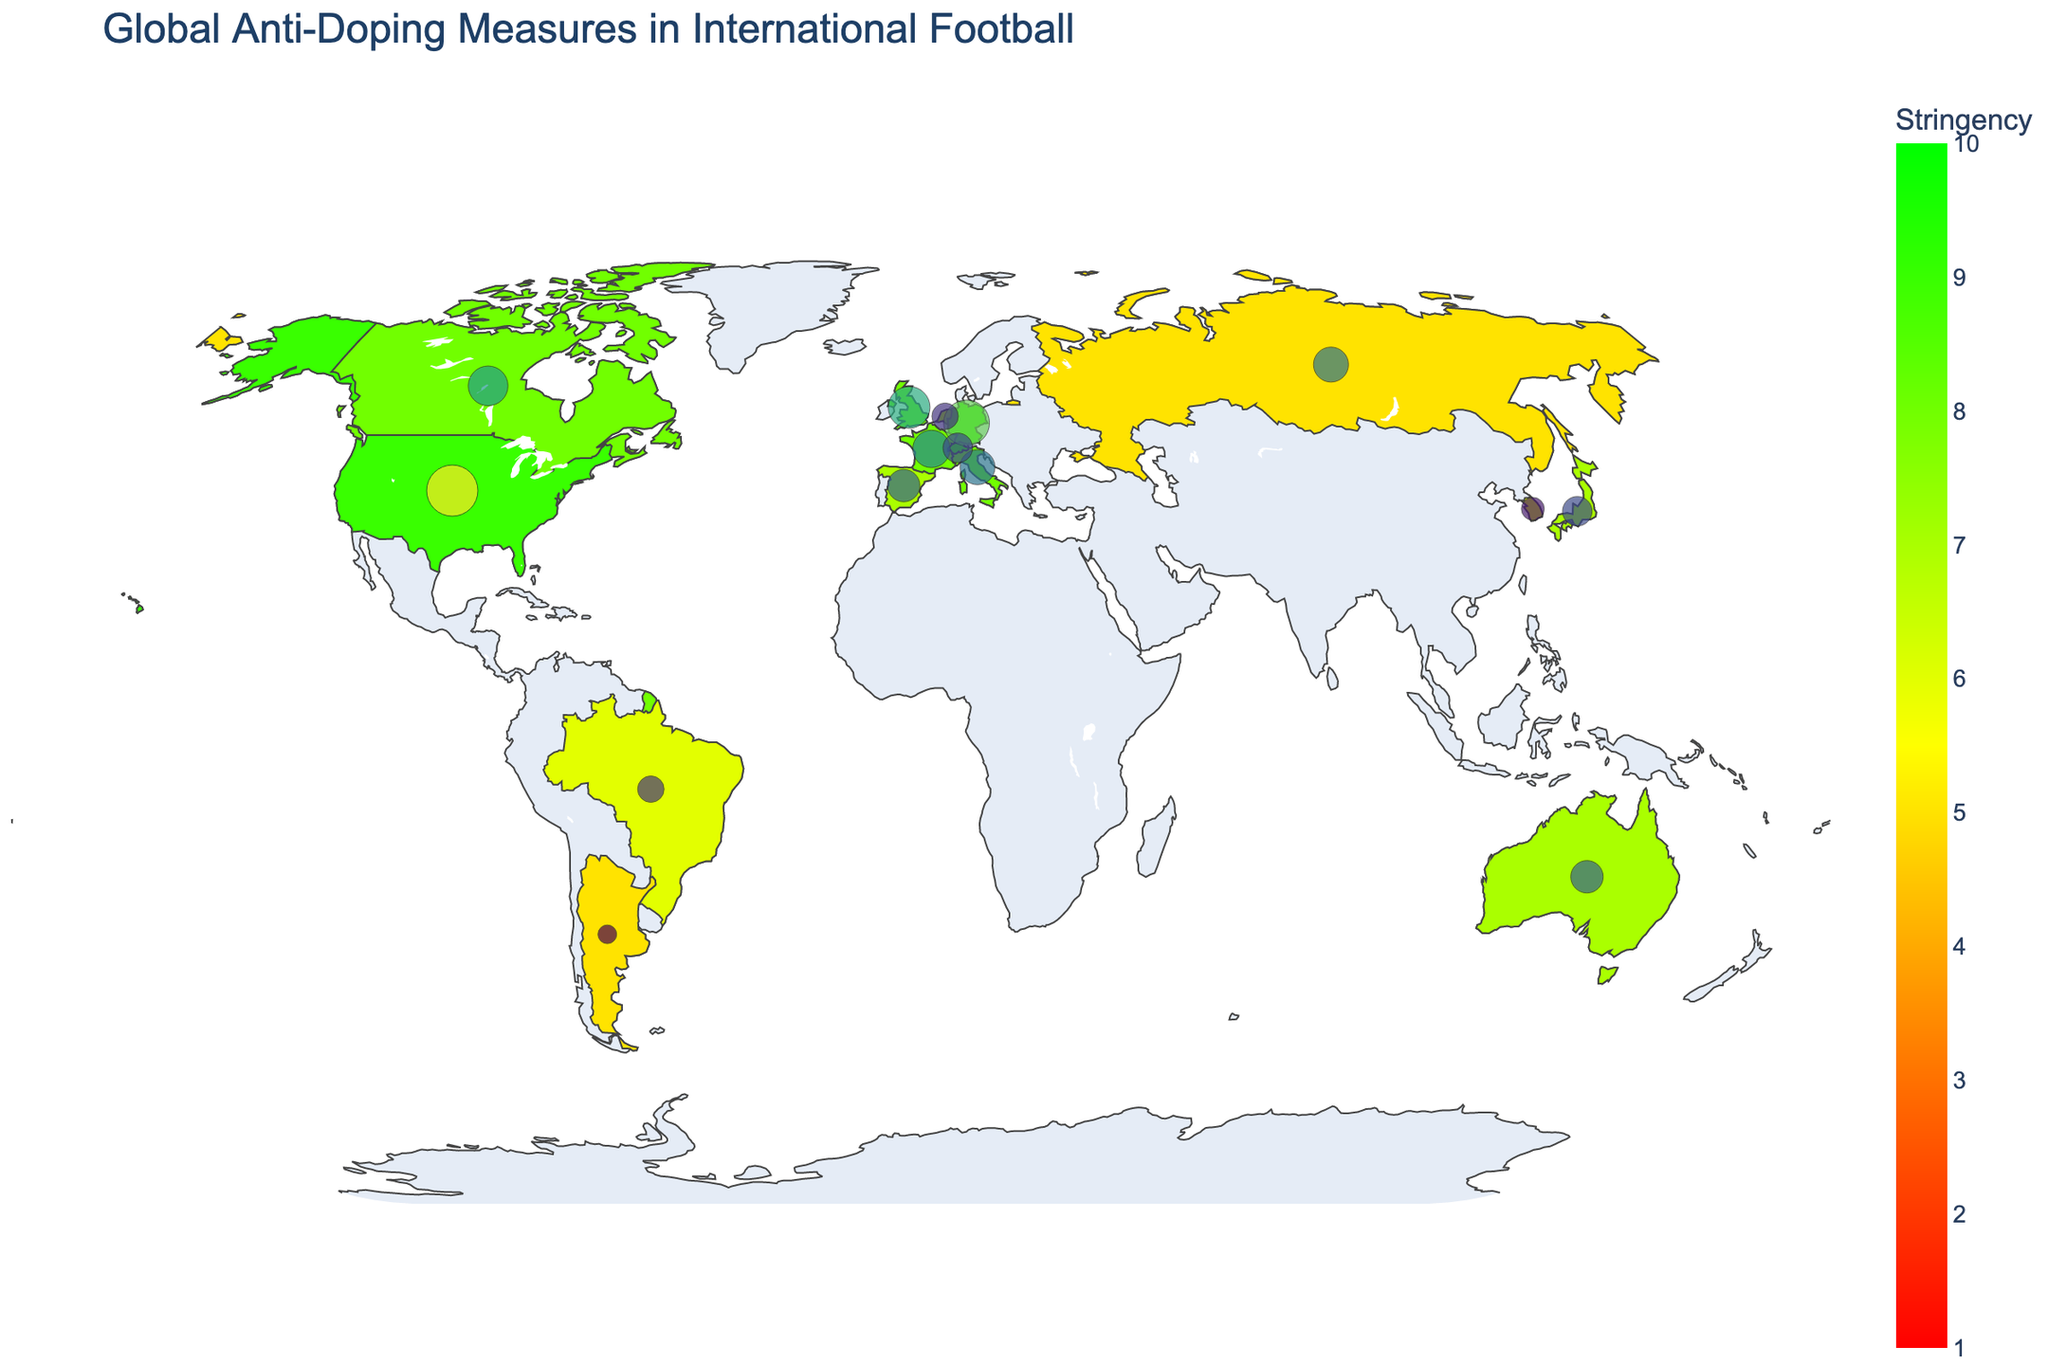How many countries have an anti-doping stringency of 9? The map indicates anti-doping stringency by color. By checking countries colored green (indicating high stringency), we see Germany, United States, and Switzerland have a stringency of 9.
Answer: 3 Which country has the highest number of testing facilities? Bubbles on the map denote the number of testing facilities, with the largest bubble representing the highest count. The United States has the highest number of facilities with 15.
Answer: United States What is the average anti-doping stringency of all the countries listed? Sum the stringency values (9+8+8+7+7+6+5+9+7+8+8+7+6+5+9 = 109), and divide by the number of countries (15). The average is 109/15 which is approximately 7.27.
Answer: 7.27 Which countries have a testing facilities count greater than 10? By comparing the country bubbles on the map, the countries with bubbles indicating counts over 10 are United States (15) and Germany (12).
Answer: United States, Germany How does the doping stringency in the United Kingdom compare to Russia? The map shows the UK with a stringency of 8, while Russia has a 5. Thus, the UK's stringency is higher than Russia's.
Answer: UK's is higher What notable sportsmanship initiative is associated with France? Hovering over France on the map reveals the "Ethical Sport Charter" as France's notable sportsmanship initiative.
Answer: Ethical Sport Charter Which country in South America is included in this map, and what is its doping stringency? By examining the map of countries, the only South American country listed is Brazil, which has a doping stringency of 6.
Answer: Brazil, 6 How many countries have testing facilities between 5 and 7 inclusive? By observing the bubbles' sizes and the hover data, France (8), Japan (5), Russia (7), Italy (7), Canada (9), Switzerland (5) fall into the range, totaling 6.
Answer: 6 What is the noted sportsmanship initiative for Japan, and how many testing facilities do they have? Hovering over Japan on the map reveals they have 5 testing facilities and the "Clean Sport Pledge" initiative.
Answer: Clean Sport Pledge, 5 What countries have an anti-doping stringency score of 7 or higher? Listing the countries from the map with a stringency score of 7 or higher: Germany, UK, France, Australia, Japan, US, Spain, Italy, Canada, Netherlands, Switzerland.
Answer: 11 